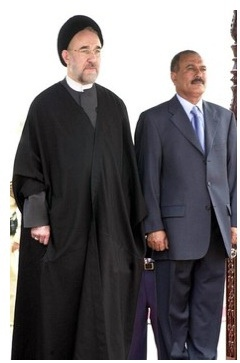Describe the objects in this image and their specific colors. I can see people in white, black, gray, and tan tones, people in white, black, and gray tones, and tie in white, lavender, darkgray, and gray tones in this image. 